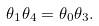Convert formula to latex. <formula><loc_0><loc_0><loc_500><loc_500>\theta _ { 1 } \theta _ { 4 } = \theta _ { 0 } \theta _ { 3 } .</formula> 